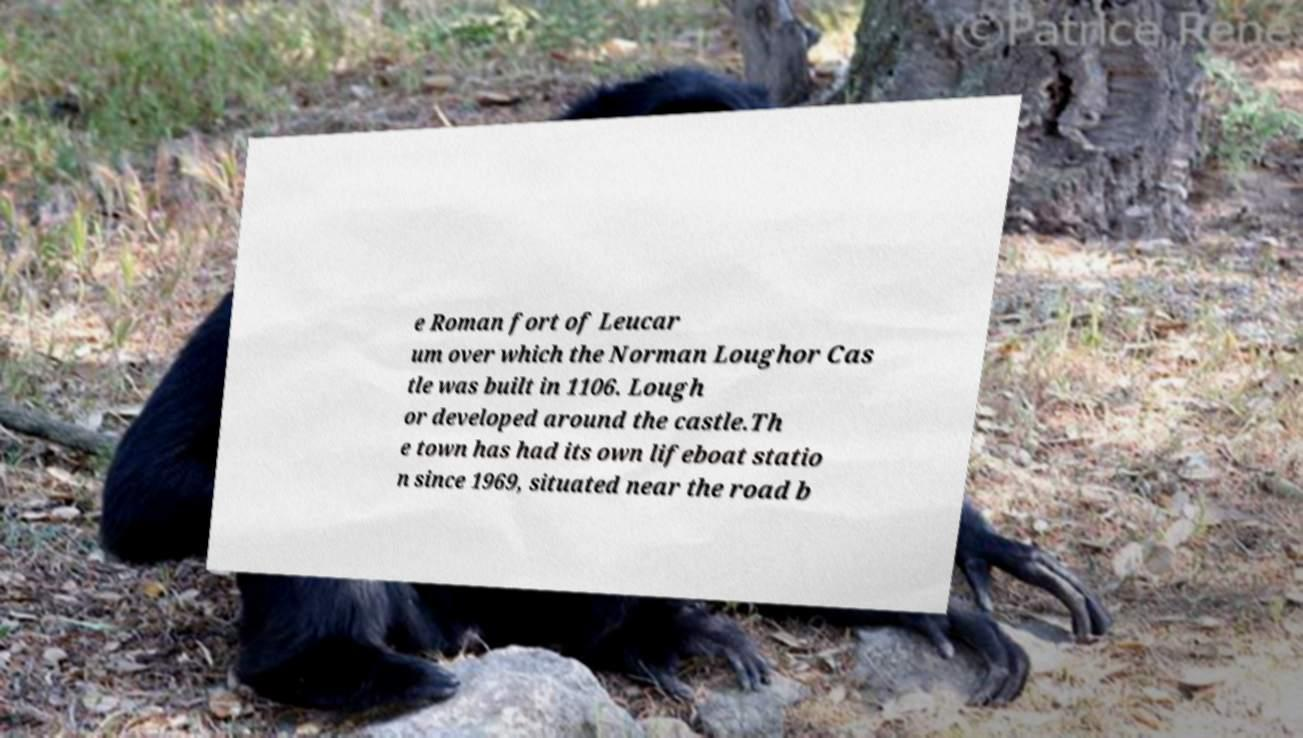I need the written content from this picture converted into text. Can you do that? e Roman fort of Leucar um over which the Norman Loughor Cas tle was built in 1106. Lough or developed around the castle.Th e town has had its own lifeboat statio n since 1969, situated near the road b 